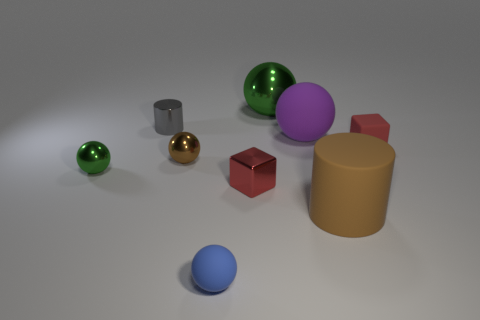Subtract all big purple rubber spheres. How many spheres are left? 4 Add 1 big blue matte cubes. How many objects exist? 10 Subtract all brown balls. How many balls are left? 4 Subtract 1 cubes. How many cubes are left? 1 Subtract all yellow cylinders. How many green spheres are left? 2 Subtract all yellow blocks. Subtract all gray cylinders. How many blocks are left? 2 Subtract all tiny red rubber cylinders. Subtract all big green metallic things. How many objects are left? 8 Add 8 blue rubber objects. How many blue rubber objects are left? 9 Add 4 big brown balls. How many big brown balls exist? 4 Subtract 1 red cubes. How many objects are left? 8 